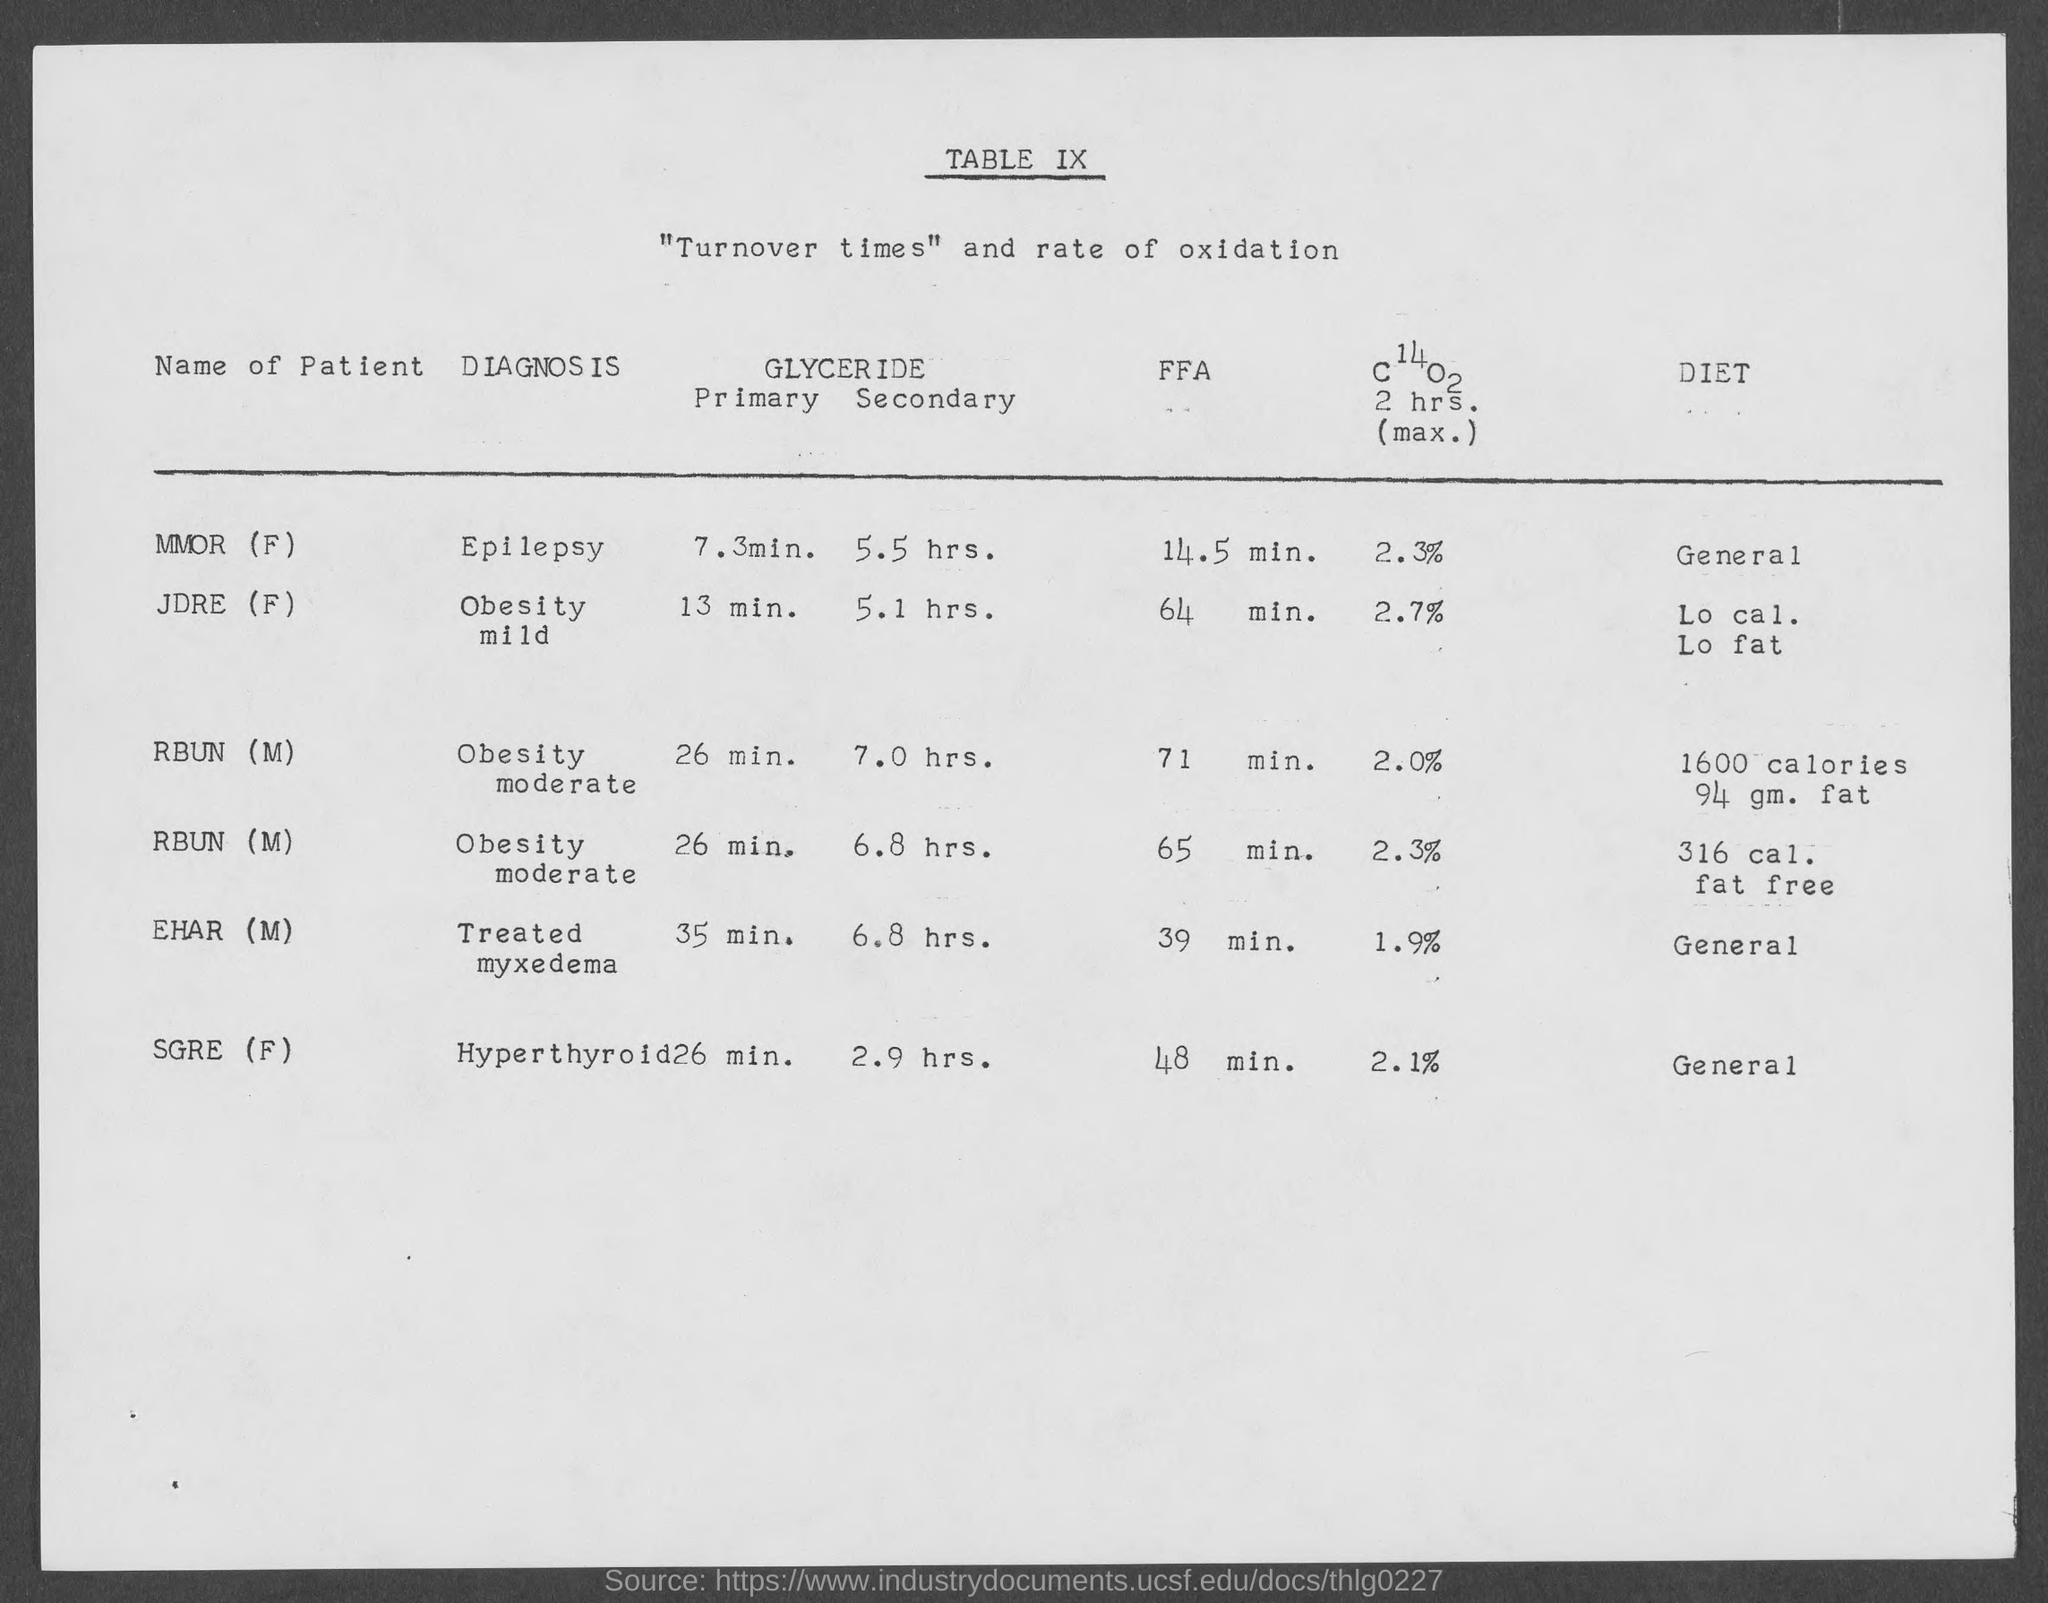What is the table no.?
Keep it short and to the point. Table ix. What is the diagnosis for mmor (f)?
Offer a terse response. Epilepsy. What is the diagnosis for jdre (f)?
Your answer should be very brief. Obesity Mild. What is the diagnosis for rbun(m)?
Your answer should be compact. Obesity moderate. What is the diagnosis for ehar (m)?
Provide a succinct answer. Treated myxedema. What is the diagnosis for sgre (f)?
Ensure brevity in your answer.  Hyperthyroid. What is the diet for mmor (f)?
Keep it short and to the point. General. What is the diet for ehar (m)?
Your answer should be compact. General. What is the diet for sgre (f)?
Ensure brevity in your answer.  General. What is the ffa for mmor(f)?
Your response must be concise. 14.5 min. 